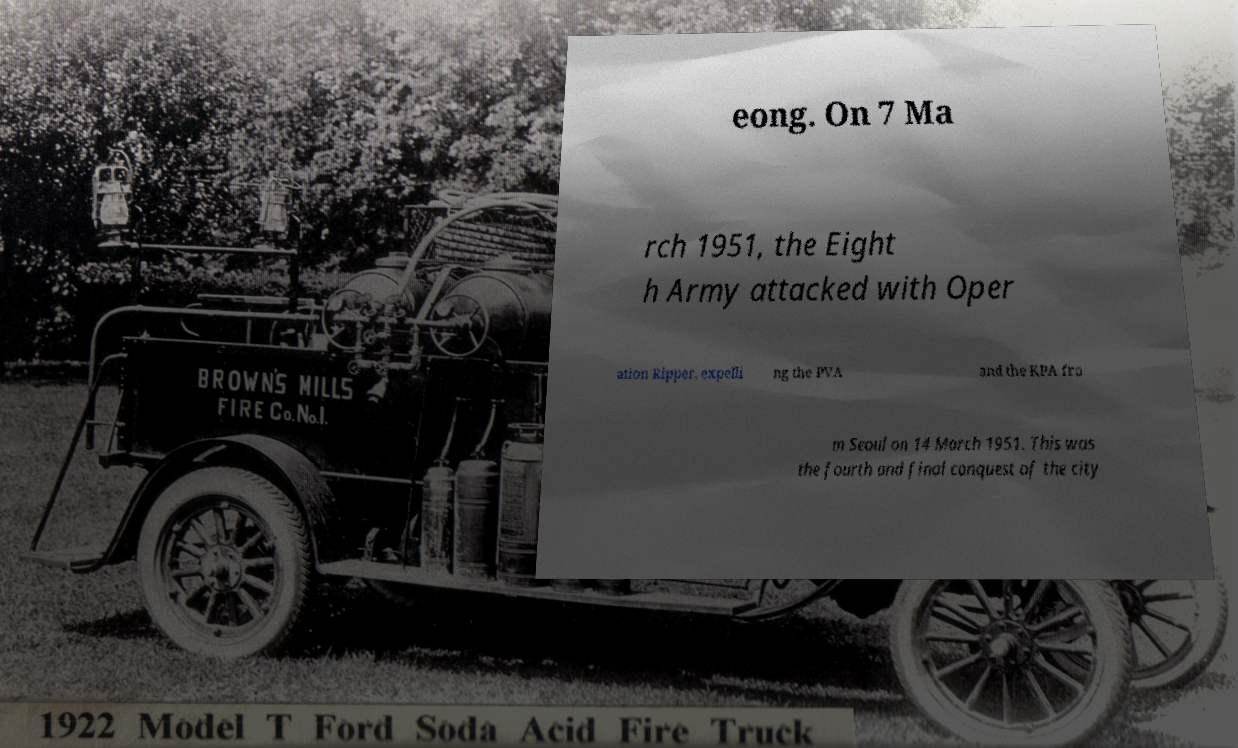Could you extract and type out the text from this image? eong. On 7 Ma rch 1951, the Eight h Army attacked with Oper ation Ripper, expelli ng the PVA and the KPA fro m Seoul on 14 March 1951. This was the fourth and final conquest of the city 